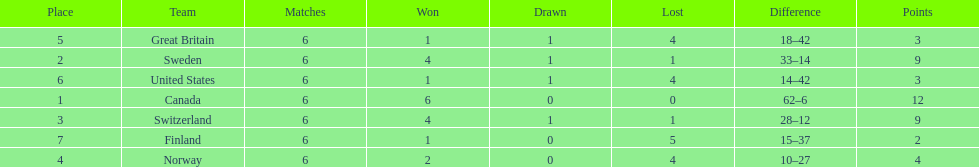Which country finished below the united states? Finland. 